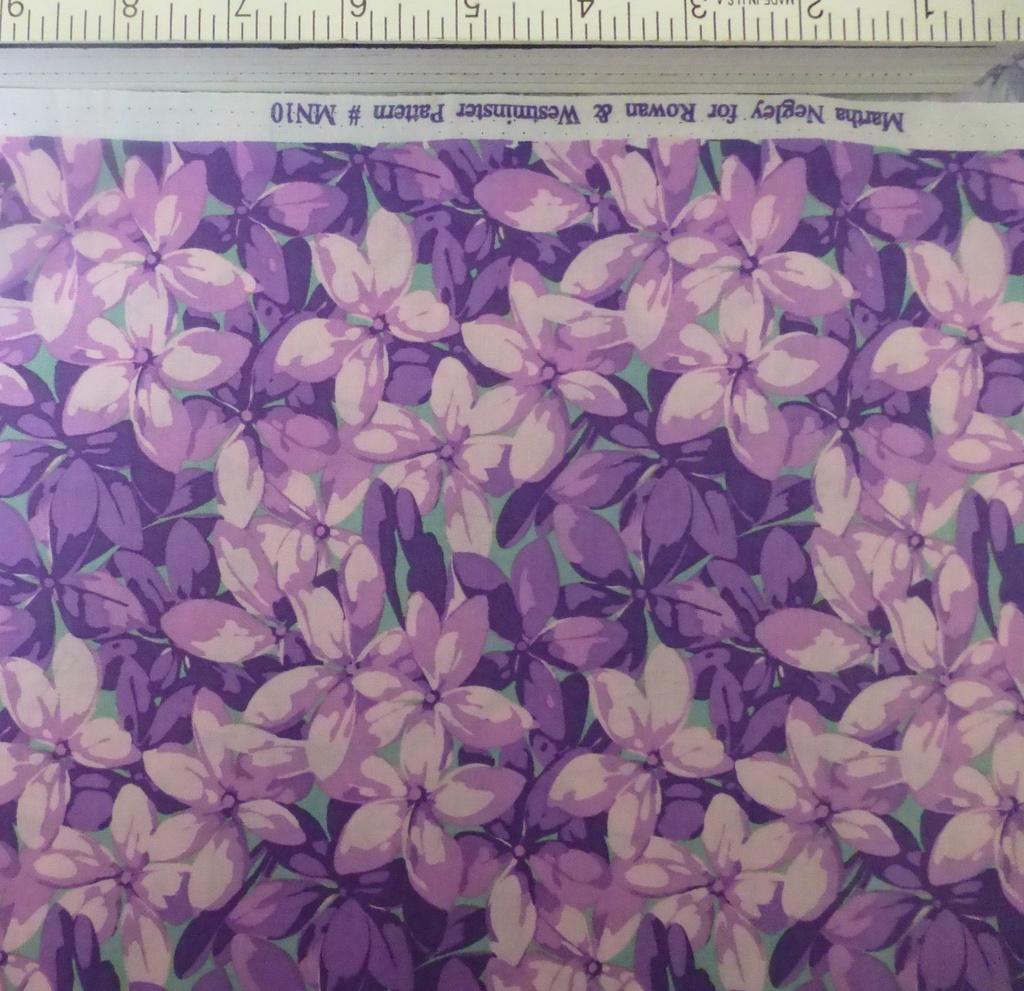What pattern number is this?
Provide a succinct answer. Mn10. What pattern name is this?
Your answer should be compact. Unanswerable. 